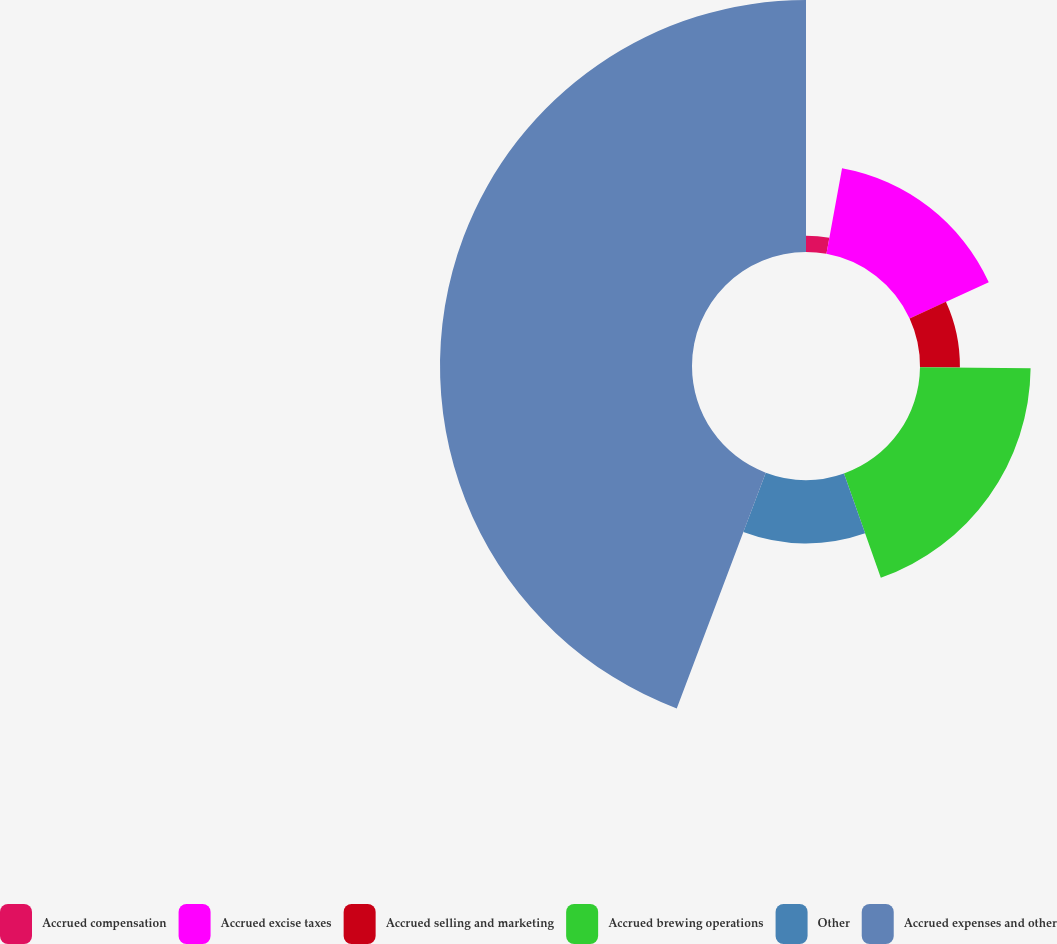Convert chart to OTSL. <chart><loc_0><loc_0><loc_500><loc_500><pie_chart><fcel>Accrued compensation<fcel>Accrued excise taxes<fcel>Accrued selling and marketing<fcel>Accrued brewing operations<fcel>Other<fcel>Accrued expenses and other<nl><fcel>2.87%<fcel>15.29%<fcel>7.01%<fcel>19.43%<fcel>11.15%<fcel>44.26%<nl></chart> 